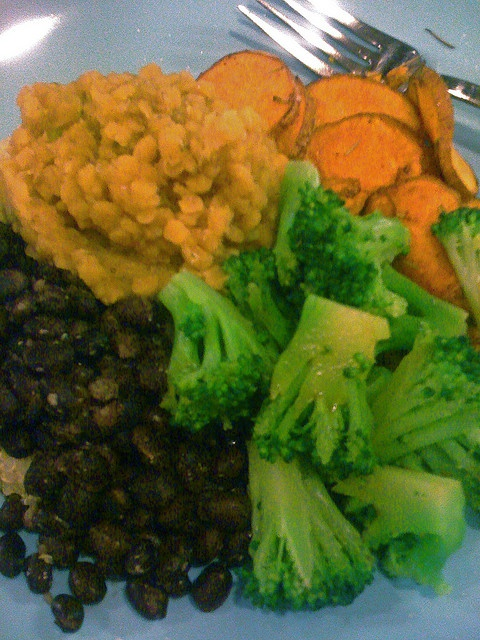Describe the objects in this image and their specific colors. I can see broccoli in darkgray, darkgreen, and green tones, broccoli in darkgray, darkgreen, and green tones, carrot in darkgray, orange, brown, and maroon tones, fork in darkgray, white, gray, and darkgreen tones, and carrot in darkgray, olive, and orange tones in this image. 